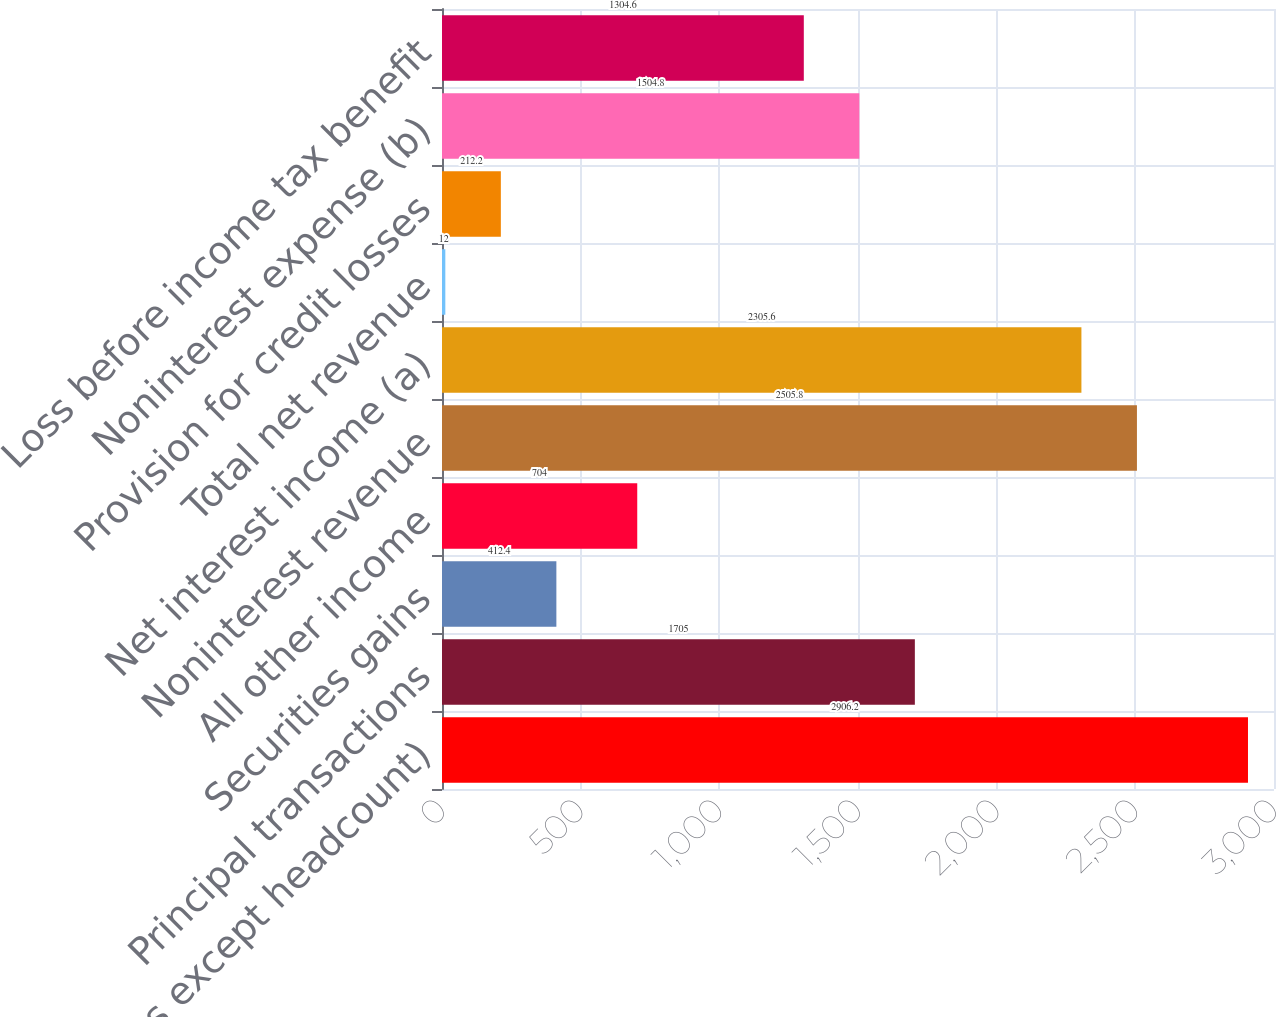Convert chart to OTSL. <chart><loc_0><loc_0><loc_500><loc_500><bar_chart><fcel>(in millions except headcount)<fcel>Principal transactions<fcel>Securities gains<fcel>All other income<fcel>Noninterest revenue<fcel>Net interest income (a)<fcel>Total net revenue<fcel>Provision for credit losses<fcel>Noninterest expense (b)<fcel>Loss before income tax benefit<nl><fcel>2906.2<fcel>1705<fcel>412.4<fcel>704<fcel>2505.8<fcel>2305.6<fcel>12<fcel>212.2<fcel>1504.8<fcel>1304.6<nl></chart> 